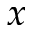Convert formula to latex. <formula><loc_0><loc_0><loc_500><loc_500>x</formula> 